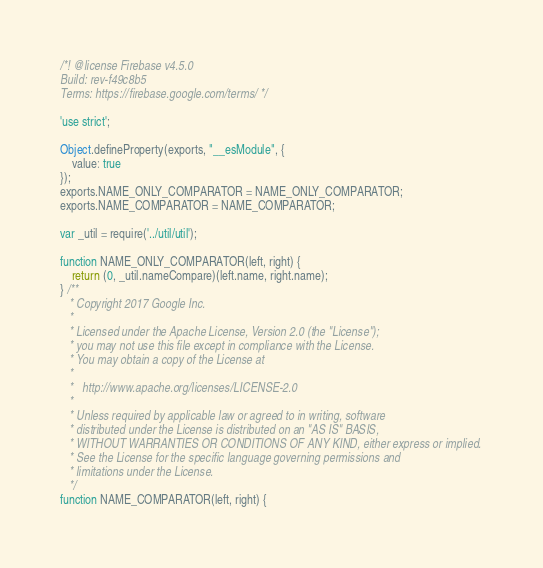<code> <loc_0><loc_0><loc_500><loc_500><_JavaScript_>/*! @license Firebase v4.5.0
Build: rev-f49c8b5
Terms: https://firebase.google.com/terms/ */

'use strict';

Object.defineProperty(exports, "__esModule", {
    value: true
});
exports.NAME_ONLY_COMPARATOR = NAME_ONLY_COMPARATOR;
exports.NAME_COMPARATOR = NAME_COMPARATOR;

var _util = require('../util/util');

function NAME_ONLY_COMPARATOR(left, right) {
    return (0, _util.nameCompare)(left.name, right.name);
} /**
   * Copyright 2017 Google Inc.
   *
   * Licensed under the Apache License, Version 2.0 (the "License");
   * you may not use this file except in compliance with the License.
   * You may obtain a copy of the License at
   *
   *   http://www.apache.org/licenses/LICENSE-2.0
   *
   * Unless required by applicable law or agreed to in writing, software
   * distributed under the License is distributed on an "AS IS" BASIS,
   * WITHOUT WARRANTIES OR CONDITIONS OF ANY KIND, either express or implied.
   * See the License for the specific language governing permissions and
   * limitations under the License.
   */
function NAME_COMPARATOR(left, right) {</code> 